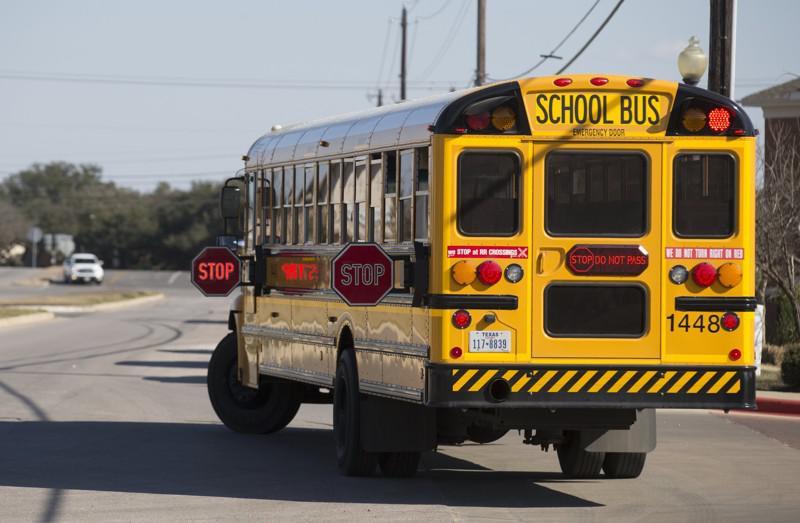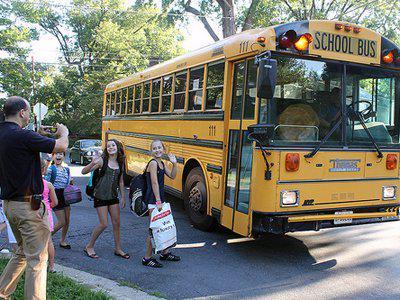The first image is the image on the left, the second image is the image on the right. Analyze the images presented: Is the assertion "An image shows a man standing to the left, and at least one child in front of the door of a flat-fronted school bus." valid? Answer yes or no. Yes. 